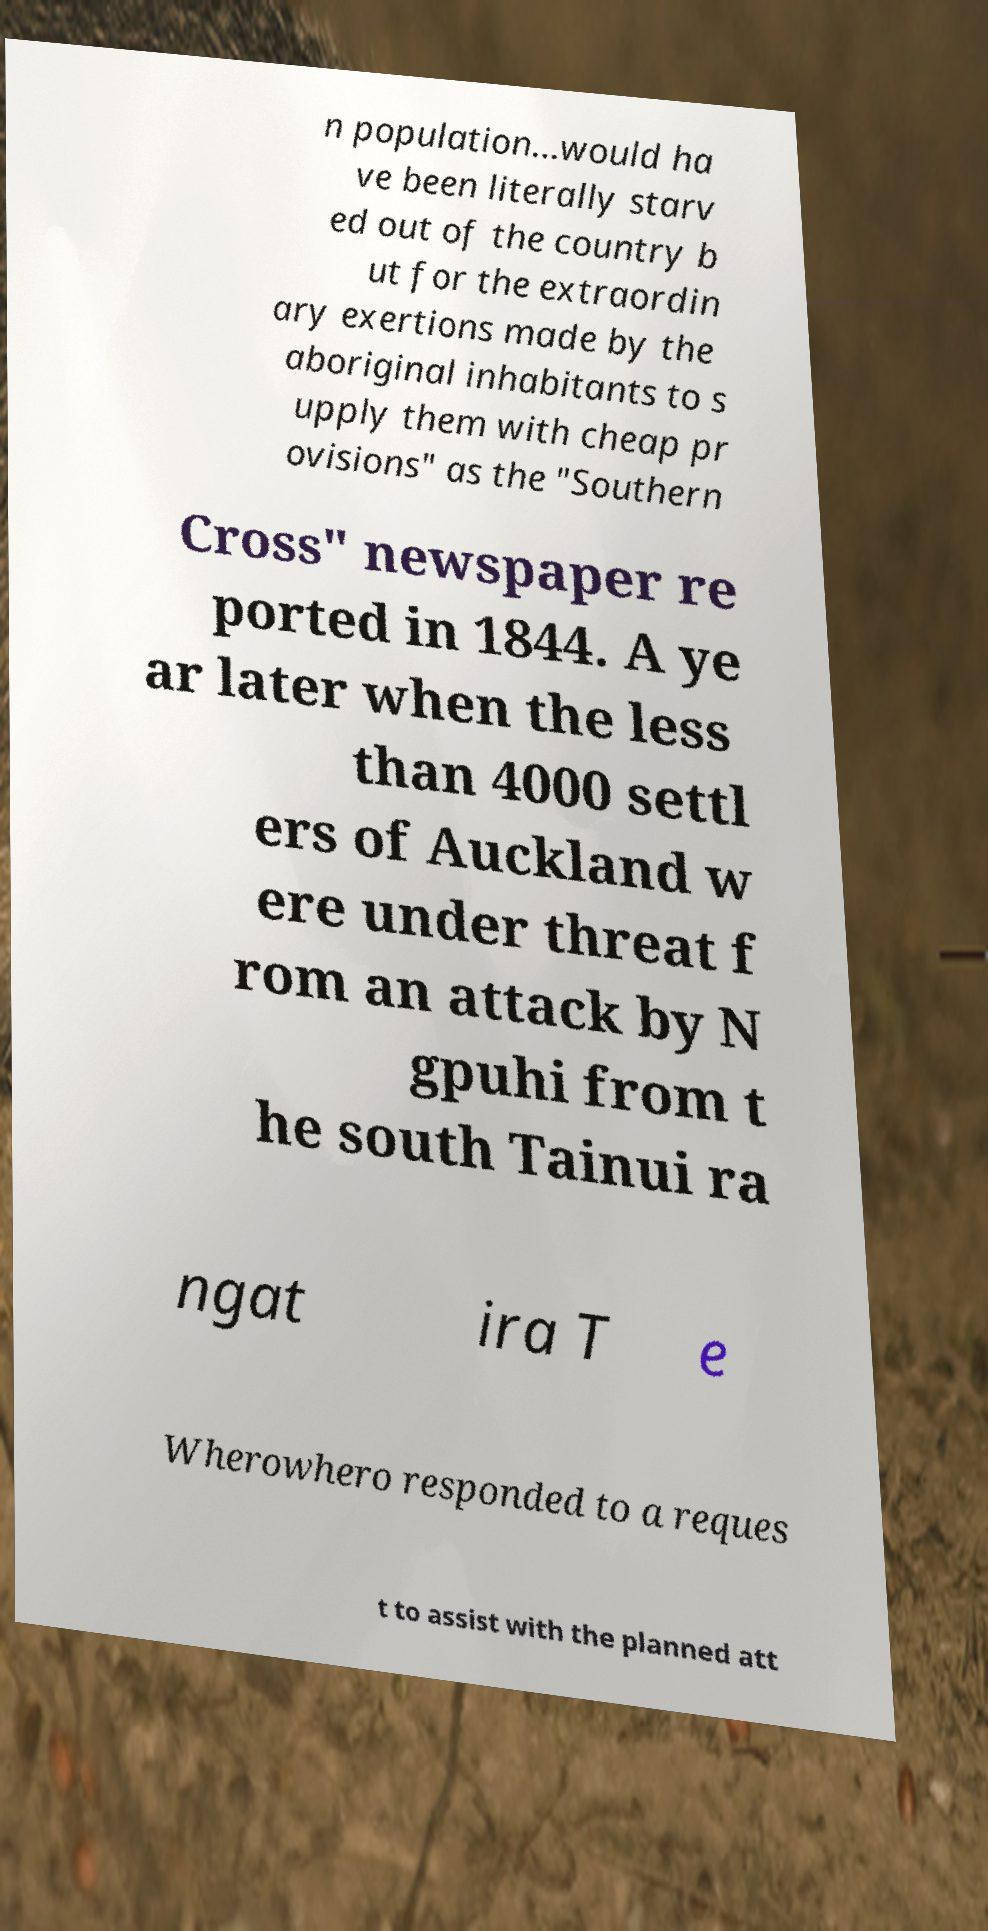For documentation purposes, I need the text within this image transcribed. Could you provide that? n population…would ha ve been literally starv ed out of the country b ut for the extraordin ary exertions made by the aboriginal inhabitants to s upply them with cheap pr ovisions" as the "Southern Cross" newspaper re ported in 1844. A ye ar later when the less than 4000 settl ers of Auckland w ere under threat f rom an attack by N gpuhi from t he south Tainui ra ngat ira T e Wherowhero responded to a reques t to assist with the planned att 